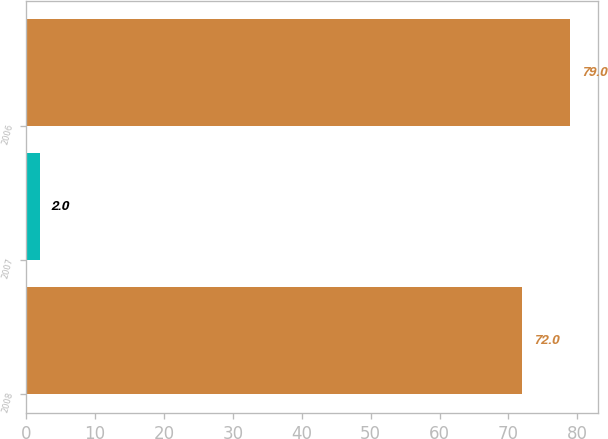Convert chart to OTSL. <chart><loc_0><loc_0><loc_500><loc_500><bar_chart><fcel>2008<fcel>2007<fcel>2006<nl><fcel>72<fcel>2<fcel>79<nl></chart> 